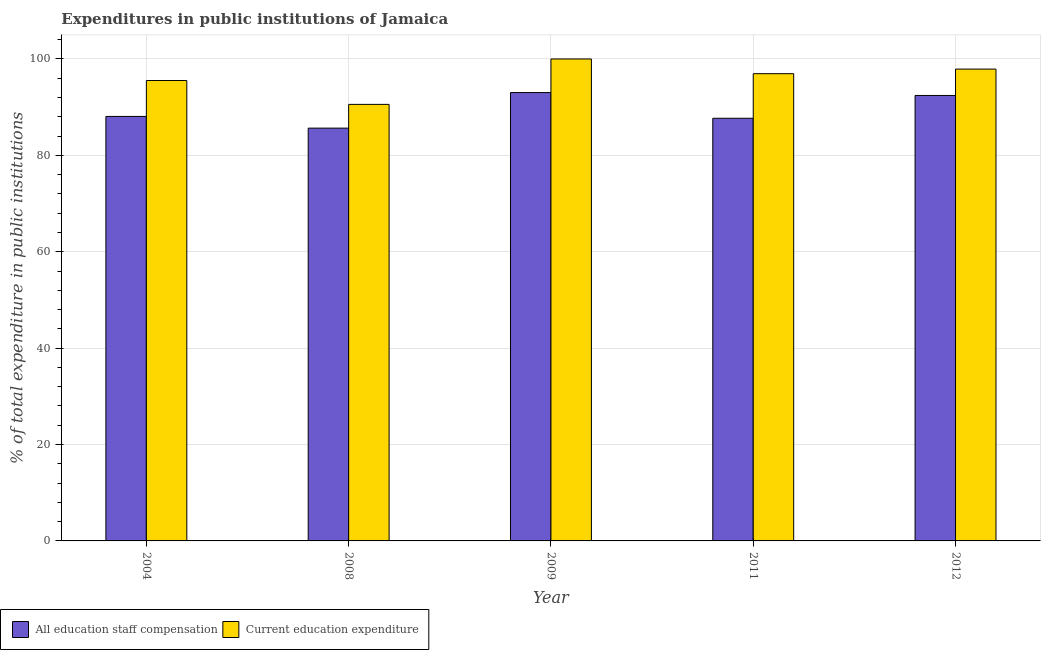How many groups of bars are there?
Give a very brief answer. 5. How many bars are there on the 5th tick from the right?
Your response must be concise. 2. What is the expenditure in staff compensation in 2004?
Give a very brief answer. 88.08. Across all years, what is the maximum expenditure in education?
Provide a succinct answer. 100. Across all years, what is the minimum expenditure in education?
Offer a very short reply. 90.58. In which year was the expenditure in staff compensation maximum?
Make the answer very short. 2009. What is the total expenditure in education in the graph?
Give a very brief answer. 480.96. What is the difference between the expenditure in staff compensation in 2004 and that in 2008?
Your answer should be very brief. 2.43. What is the difference between the expenditure in staff compensation in 2004 and the expenditure in education in 2009?
Make the answer very short. -4.95. What is the average expenditure in staff compensation per year?
Your answer should be compact. 89.38. In the year 2008, what is the difference between the expenditure in education and expenditure in staff compensation?
Your answer should be compact. 0. What is the ratio of the expenditure in education in 2008 to that in 2012?
Provide a succinct answer. 0.93. What is the difference between the highest and the second highest expenditure in education?
Give a very brief answer. 2.1. What is the difference between the highest and the lowest expenditure in education?
Offer a very short reply. 9.42. Is the sum of the expenditure in education in 2008 and 2009 greater than the maximum expenditure in staff compensation across all years?
Offer a very short reply. Yes. What does the 1st bar from the left in 2008 represents?
Provide a short and direct response. All education staff compensation. What does the 2nd bar from the right in 2004 represents?
Offer a terse response. All education staff compensation. How many bars are there?
Give a very brief answer. 10. How many years are there in the graph?
Give a very brief answer. 5. What is the difference between two consecutive major ticks on the Y-axis?
Offer a very short reply. 20. Are the values on the major ticks of Y-axis written in scientific E-notation?
Provide a succinct answer. No. Does the graph contain grids?
Your response must be concise. Yes. How many legend labels are there?
Your answer should be compact. 2. What is the title of the graph?
Offer a terse response. Expenditures in public institutions of Jamaica. What is the label or title of the Y-axis?
Your answer should be very brief. % of total expenditure in public institutions. What is the % of total expenditure in public institutions in All education staff compensation in 2004?
Ensure brevity in your answer.  88.08. What is the % of total expenditure in public institutions in Current education expenditure in 2004?
Ensure brevity in your answer.  95.53. What is the % of total expenditure in public institutions in All education staff compensation in 2008?
Make the answer very short. 85.65. What is the % of total expenditure in public institutions in Current education expenditure in 2008?
Provide a short and direct response. 90.58. What is the % of total expenditure in public institutions in All education staff compensation in 2009?
Your response must be concise. 93.03. What is the % of total expenditure in public institutions of Current education expenditure in 2009?
Your response must be concise. 100. What is the % of total expenditure in public institutions in All education staff compensation in 2011?
Give a very brief answer. 87.69. What is the % of total expenditure in public institutions of Current education expenditure in 2011?
Keep it short and to the point. 96.95. What is the % of total expenditure in public institutions in All education staff compensation in 2012?
Your response must be concise. 92.43. What is the % of total expenditure in public institutions of Current education expenditure in 2012?
Your answer should be very brief. 97.9. Across all years, what is the maximum % of total expenditure in public institutions in All education staff compensation?
Your answer should be very brief. 93.03. Across all years, what is the maximum % of total expenditure in public institutions of Current education expenditure?
Make the answer very short. 100. Across all years, what is the minimum % of total expenditure in public institutions of All education staff compensation?
Offer a very short reply. 85.65. Across all years, what is the minimum % of total expenditure in public institutions of Current education expenditure?
Provide a succinct answer. 90.58. What is the total % of total expenditure in public institutions of All education staff compensation in the graph?
Provide a succinct answer. 446.88. What is the total % of total expenditure in public institutions of Current education expenditure in the graph?
Offer a terse response. 480.96. What is the difference between the % of total expenditure in public institutions in All education staff compensation in 2004 and that in 2008?
Your answer should be very brief. 2.43. What is the difference between the % of total expenditure in public institutions of Current education expenditure in 2004 and that in 2008?
Your answer should be very brief. 4.95. What is the difference between the % of total expenditure in public institutions in All education staff compensation in 2004 and that in 2009?
Your answer should be very brief. -4.95. What is the difference between the % of total expenditure in public institutions in Current education expenditure in 2004 and that in 2009?
Provide a succinct answer. -4.47. What is the difference between the % of total expenditure in public institutions of All education staff compensation in 2004 and that in 2011?
Provide a succinct answer. 0.38. What is the difference between the % of total expenditure in public institutions in Current education expenditure in 2004 and that in 2011?
Your answer should be compact. -1.42. What is the difference between the % of total expenditure in public institutions in All education staff compensation in 2004 and that in 2012?
Offer a very short reply. -4.35. What is the difference between the % of total expenditure in public institutions in Current education expenditure in 2004 and that in 2012?
Your response must be concise. -2.37. What is the difference between the % of total expenditure in public institutions in All education staff compensation in 2008 and that in 2009?
Offer a terse response. -7.38. What is the difference between the % of total expenditure in public institutions in Current education expenditure in 2008 and that in 2009?
Give a very brief answer. -9.42. What is the difference between the % of total expenditure in public institutions in All education staff compensation in 2008 and that in 2011?
Make the answer very short. -2.04. What is the difference between the % of total expenditure in public institutions in Current education expenditure in 2008 and that in 2011?
Ensure brevity in your answer.  -6.37. What is the difference between the % of total expenditure in public institutions of All education staff compensation in 2008 and that in 2012?
Make the answer very short. -6.78. What is the difference between the % of total expenditure in public institutions of Current education expenditure in 2008 and that in 2012?
Your answer should be compact. -7.32. What is the difference between the % of total expenditure in public institutions in All education staff compensation in 2009 and that in 2011?
Ensure brevity in your answer.  5.33. What is the difference between the % of total expenditure in public institutions of Current education expenditure in 2009 and that in 2011?
Your response must be concise. 3.05. What is the difference between the % of total expenditure in public institutions of All education staff compensation in 2009 and that in 2012?
Your answer should be very brief. 0.6. What is the difference between the % of total expenditure in public institutions of Current education expenditure in 2009 and that in 2012?
Ensure brevity in your answer.  2.1. What is the difference between the % of total expenditure in public institutions of All education staff compensation in 2011 and that in 2012?
Your answer should be compact. -4.73. What is the difference between the % of total expenditure in public institutions in Current education expenditure in 2011 and that in 2012?
Provide a succinct answer. -0.95. What is the difference between the % of total expenditure in public institutions in All education staff compensation in 2004 and the % of total expenditure in public institutions in Current education expenditure in 2008?
Ensure brevity in your answer.  -2.5. What is the difference between the % of total expenditure in public institutions of All education staff compensation in 2004 and the % of total expenditure in public institutions of Current education expenditure in 2009?
Offer a terse response. -11.92. What is the difference between the % of total expenditure in public institutions of All education staff compensation in 2004 and the % of total expenditure in public institutions of Current education expenditure in 2011?
Offer a very short reply. -8.87. What is the difference between the % of total expenditure in public institutions in All education staff compensation in 2004 and the % of total expenditure in public institutions in Current education expenditure in 2012?
Offer a very short reply. -9.82. What is the difference between the % of total expenditure in public institutions in All education staff compensation in 2008 and the % of total expenditure in public institutions in Current education expenditure in 2009?
Provide a succinct answer. -14.35. What is the difference between the % of total expenditure in public institutions in All education staff compensation in 2008 and the % of total expenditure in public institutions in Current education expenditure in 2011?
Your answer should be very brief. -11.3. What is the difference between the % of total expenditure in public institutions in All education staff compensation in 2008 and the % of total expenditure in public institutions in Current education expenditure in 2012?
Keep it short and to the point. -12.25. What is the difference between the % of total expenditure in public institutions of All education staff compensation in 2009 and the % of total expenditure in public institutions of Current education expenditure in 2011?
Offer a very short reply. -3.92. What is the difference between the % of total expenditure in public institutions in All education staff compensation in 2009 and the % of total expenditure in public institutions in Current education expenditure in 2012?
Your response must be concise. -4.87. What is the difference between the % of total expenditure in public institutions of All education staff compensation in 2011 and the % of total expenditure in public institutions of Current education expenditure in 2012?
Offer a terse response. -10.21. What is the average % of total expenditure in public institutions of All education staff compensation per year?
Provide a short and direct response. 89.38. What is the average % of total expenditure in public institutions of Current education expenditure per year?
Offer a terse response. 96.19. In the year 2004, what is the difference between the % of total expenditure in public institutions of All education staff compensation and % of total expenditure in public institutions of Current education expenditure?
Offer a terse response. -7.45. In the year 2008, what is the difference between the % of total expenditure in public institutions in All education staff compensation and % of total expenditure in public institutions in Current education expenditure?
Keep it short and to the point. -4.93. In the year 2009, what is the difference between the % of total expenditure in public institutions in All education staff compensation and % of total expenditure in public institutions in Current education expenditure?
Your answer should be compact. -6.97. In the year 2011, what is the difference between the % of total expenditure in public institutions of All education staff compensation and % of total expenditure in public institutions of Current education expenditure?
Give a very brief answer. -9.25. In the year 2012, what is the difference between the % of total expenditure in public institutions of All education staff compensation and % of total expenditure in public institutions of Current education expenditure?
Ensure brevity in your answer.  -5.47. What is the ratio of the % of total expenditure in public institutions in All education staff compensation in 2004 to that in 2008?
Provide a short and direct response. 1.03. What is the ratio of the % of total expenditure in public institutions of Current education expenditure in 2004 to that in 2008?
Provide a short and direct response. 1.05. What is the ratio of the % of total expenditure in public institutions in All education staff compensation in 2004 to that in 2009?
Offer a very short reply. 0.95. What is the ratio of the % of total expenditure in public institutions of Current education expenditure in 2004 to that in 2009?
Your response must be concise. 0.96. What is the ratio of the % of total expenditure in public institutions of All education staff compensation in 2004 to that in 2011?
Offer a terse response. 1. What is the ratio of the % of total expenditure in public institutions of Current education expenditure in 2004 to that in 2011?
Your response must be concise. 0.99. What is the ratio of the % of total expenditure in public institutions in All education staff compensation in 2004 to that in 2012?
Provide a short and direct response. 0.95. What is the ratio of the % of total expenditure in public institutions of Current education expenditure in 2004 to that in 2012?
Keep it short and to the point. 0.98. What is the ratio of the % of total expenditure in public institutions in All education staff compensation in 2008 to that in 2009?
Provide a succinct answer. 0.92. What is the ratio of the % of total expenditure in public institutions in Current education expenditure in 2008 to that in 2009?
Your response must be concise. 0.91. What is the ratio of the % of total expenditure in public institutions of All education staff compensation in 2008 to that in 2011?
Make the answer very short. 0.98. What is the ratio of the % of total expenditure in public institutions of Current education expenditure in 2008 to that in 2011?
Give a very brief answer. 0.93. What is the ratio of the % of total expenditure in public institutions of All education staff compensation in 2008 to that in 2012?
Your answer should be very brief. 0.93. What is the ratio of the % of total expenditure in public institutions of Current education expenditure in 2008 to that in 2012?
Your response must be concise. 0.93. What is the ratio of the % of total expenditure in public institutions of All education staff compensation in 2009 to that in 2011?
Keep it short and to the point. 1.06. What is the ratio of the % of total expenditure in public institutions in Current education expenditure in 2009 to that in 2011?
Make the answer very short. 1.03. What is the ratio of the % of total expenditure in public institutions in Current education expenditure in 2009 to that in 2012?
Offer a very short reply. 1.02. What is the ratio of the % of total expenditure in public institutions of All education staff compensation in 2011 to that in 2012?
Your answer should be very brief. 0.95. What is the ratio of the % of total expenditure in public institutions of Current education expenditure in 2011 to that in 2012?
Offer a terse response. 0.99. What is the difference between the highest and the second highest % of total expenditure in public institutions of All education staff compensation?
Your response must be concise. 0.6. What is the difference between the highest and the second highest % of total expenditure in public institutions of Current education expenditure?
Ensure brevity in your answer.  2.1. What is the difference between the highest and the lowest % of total expenditure in public institutions of All education staff compensation?
Your answer should be compact. 7.38. What is the difference between the highest and the lowest % of total expenditure in public institutions in Current education expenditure?
Your response must be concise. 9.42. 